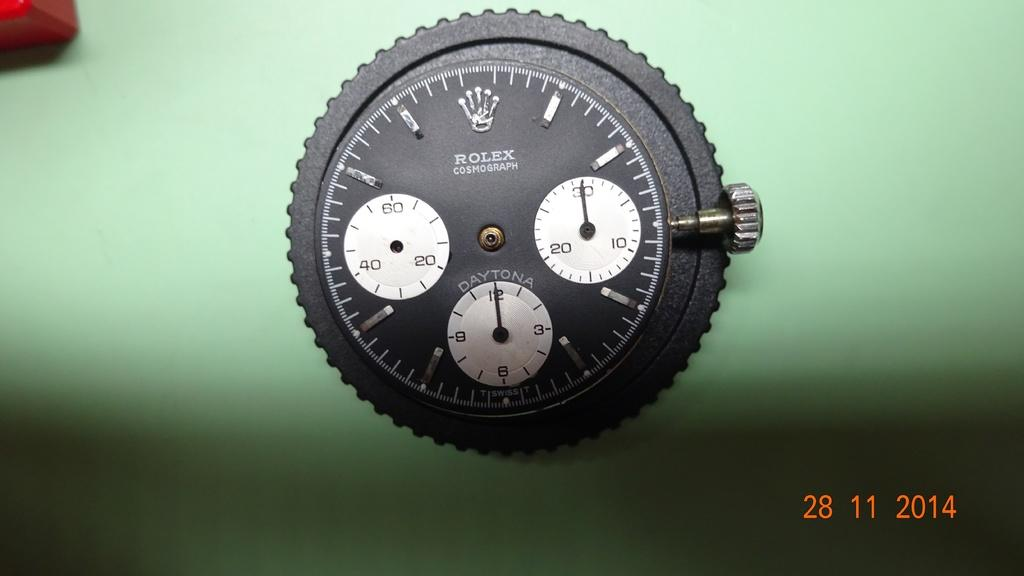<image>
Share a concise interpretation of the image provided. A picture of a Rolex watch was taken in 2014 